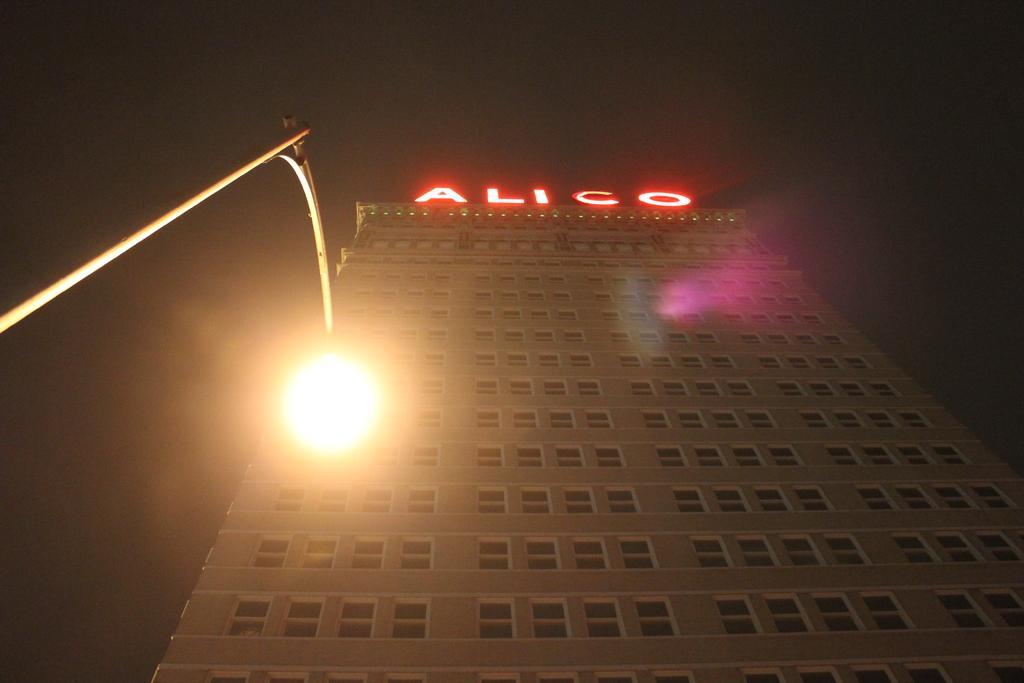What type of structure is present in the image? There is a building with walls and windows in the image. What can be seen on the left side of the image? There is a street light with a pole on the left side of the image. What is visible in the background of the image? The sky is visible in the background of the image. What type of quartz can be seen in the image? There is no quartz present in the image. Can you describe the truck parked near the building in the image? There is no truck present in the image. 